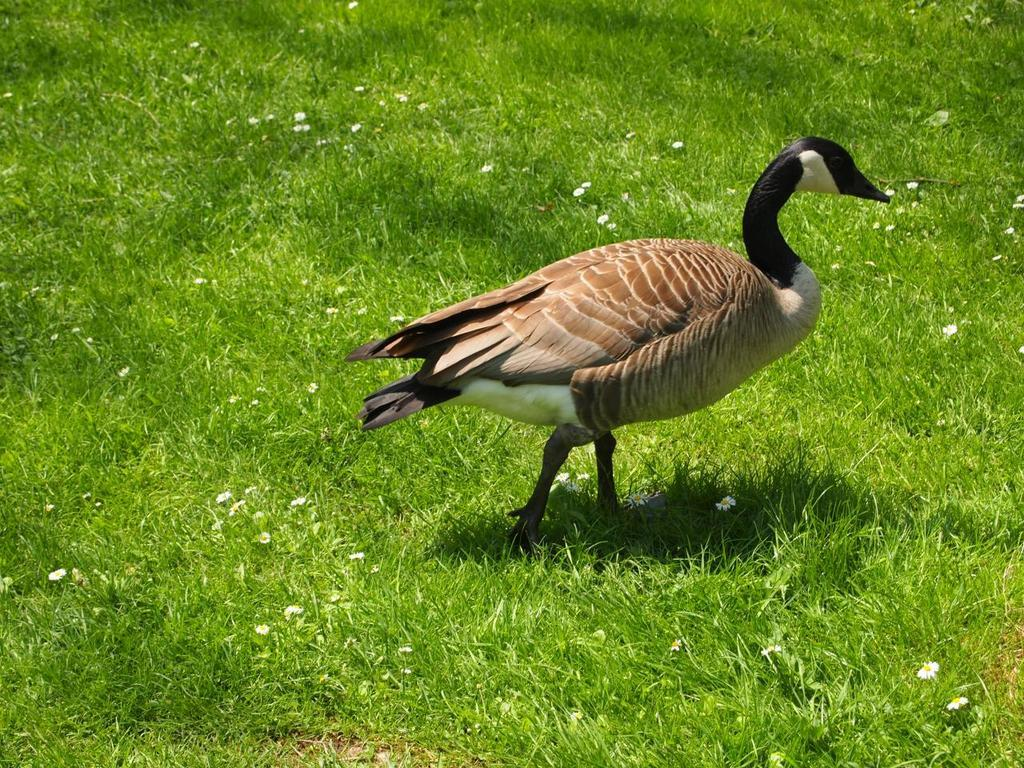What animal can be seen in the picture? There is a goose in the picture. What is the goose doing in the image? The goose is standing on the ground. What type of terrain is visible at the bottom of the image? Grass and small flowers are present at the bottom of the image. What type of cart is being used by the goose to transport the team in the image? There is no cart or team present in the image; it features a goose standing on the ground amidst grass and small flowers. 